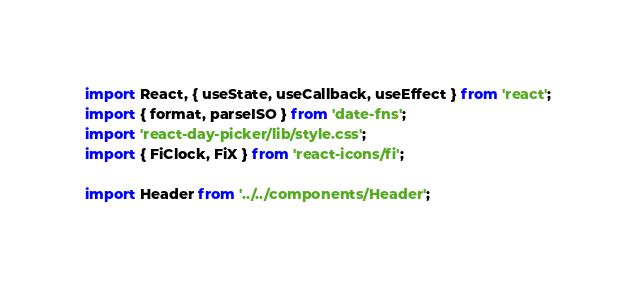Convert code to text. <code><loc_0><loc_0><loc_500><loc_500><_TypeScript_>import React, { useState, useCallback, useEffect } from 'react';
import { format, parseISO } from 'date-fns';
import 'react-day-picker/lib/style.css';
import { FiClock, FiX } from 'react-icons/fi';

import Header from '../../components/Header';
</code> 